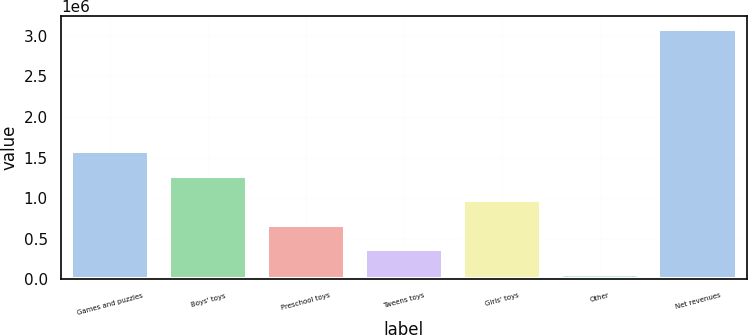<chart> <loc_0><loc_0><loc_500><loc_500><bar_chart><fcel>Games and puzzles<fcel>Boys' toys<fcel>Preschool toys<fcel>Tweens toys<fcel>Girls' toys<fcel>Other<fcel>Net revenues<nl><fcel>1.57784e+06<fcel>1.27589e+06<fcel>671972<fcel>370015<fcel>973929<fcel>68058<fcel>3.08763e+06<nl></chart> 